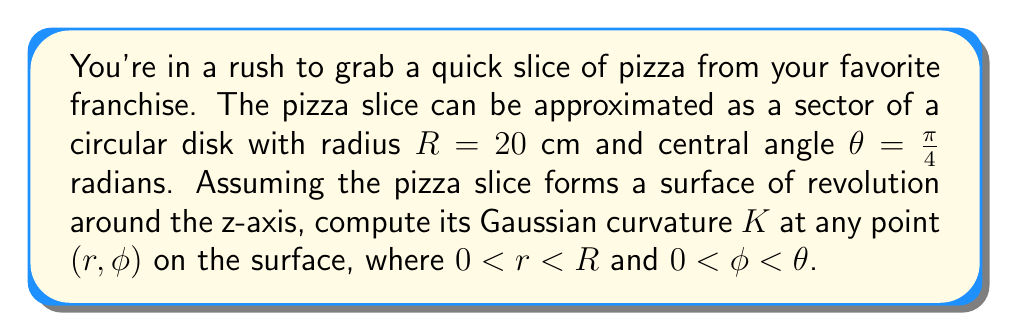What is the answer to this math problem? Let's approach this step-by-step:

1) The pizza slice can be parameterized as a surface of revolution:
   $x(r, \phi) = r \cos\phi$
   $y(r, \phi) = r \sin\phi$
   $z(r, \phi) = 0$

2) The first fundamental form coefficients are:
   $E = (\frac{\partial x}{\partial r})^2 + (\frac{\partial y}{\partial r})^2 + (\frac{\partial z}{\partial r})^2 = \cos^2\phi + \sin^2\phi = 1$
   $F = \frac{\partial x}{\partial r}\frac{\partial x}{\partial \phi} + \frac{\partial y}{\partial r}\frac{\partial y}{\partial \phi} + \frac{\partial z}{\partial r}\frac{\partial z}{\partial \phi} = -r\sin\phi\cos\phi + r\cos\phi\sin\phi = 0$
   $G = (\frac{\partial x}{\partial \phi})^2 + (\frac{\partial y}{\partial \phi})^2 + (\frac{\partial z}{\partial \phi})^2 = r^2\sin^2\phi + r^2\cos^2\phi = r^2$

3) The second fundamental form coefficients are all zero because the surface is flat:
   $e = f = g = 0$

4) The Gaussian curvature is given by:
   $$K = \frac{eg - f^2}{EG - F^2}$$

5) Substituting the values:
   $$K = \frac{0 - 0^2}{1 \cdot r^2 - 0^2} = 0$$

Therefore, the Gaussian curvature is zero at all points on the pizza slice.
Answer: $K = 0$ 